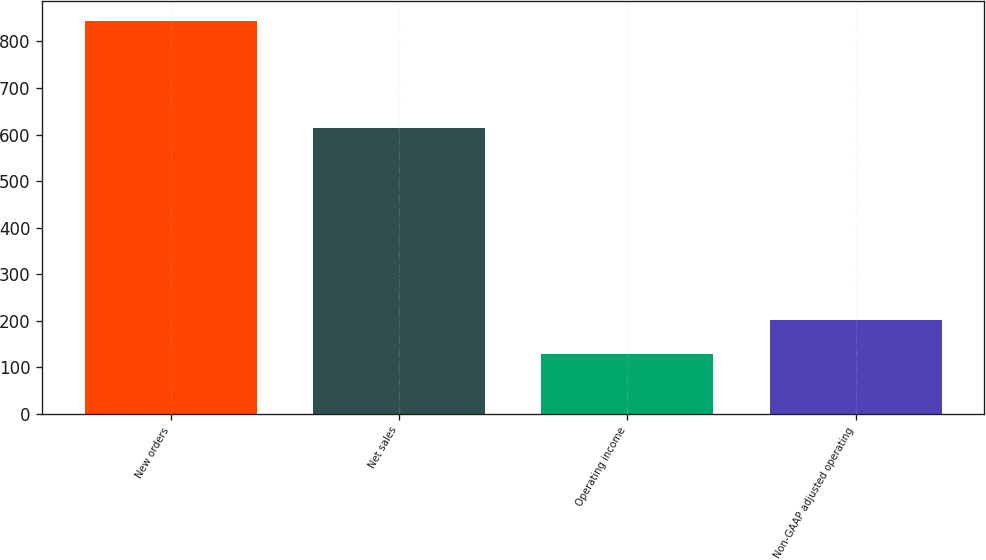Convert chart. <chart><loc_0><loc_0><loc_500><loc_500><bar_chart><fcel>New orders<fcel>Net sales<fcel>Operating income<fcel>Non-GAAP adjusted operating<nl><fcel>845<fcel>615<fcel>129<fcel>200.6<nl></chart> 